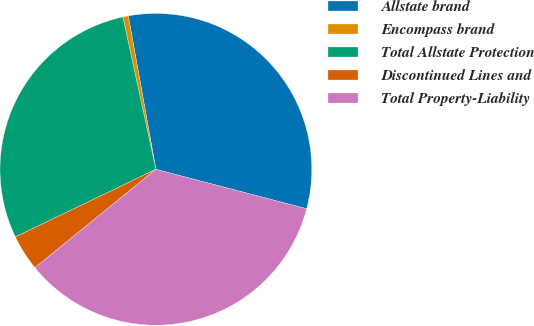<chart> <loc_0><loc_0><loc_500><loc_500><pie_chart><fcel>Allstate brand<fcel>Encompass brand<fcel>Total Allstate Protection<fcel>Discontinued Lines and<fcel>Total Property-Liability<nl><fcel>31.9%<fcel>0.57%<fcel>28.74%<fcel>3.73%<fcel>35.06%<nl></chart> 